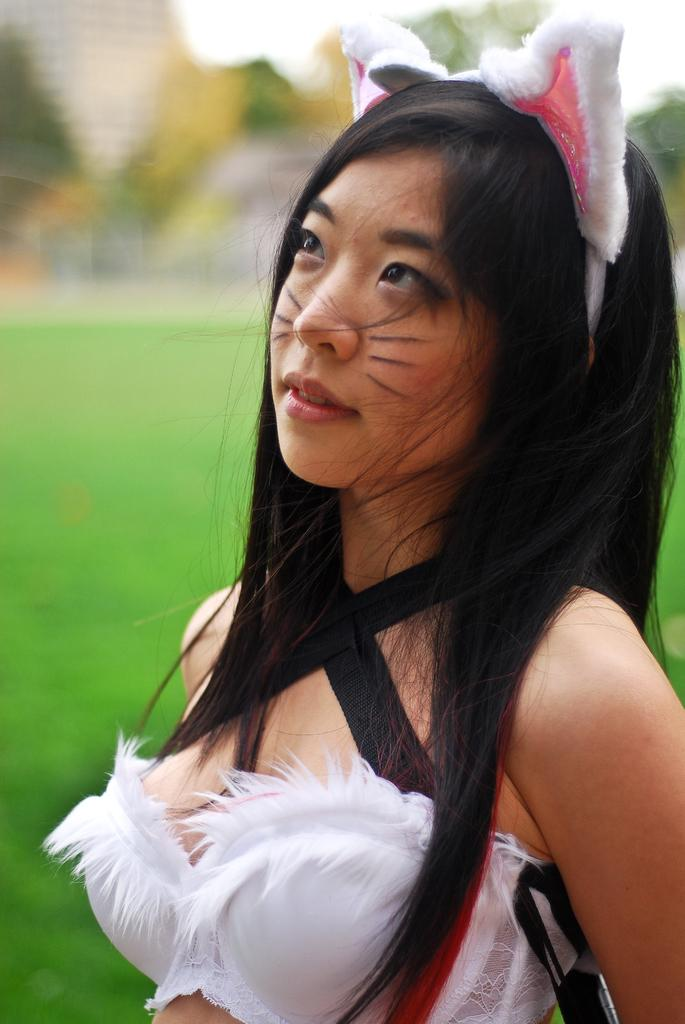Who is present in the image? There is a woman in the image. What is the woman wearing? The woman is wearing a white dress. What type of terrain is visible in the image? There is grass in the image. How would you describe the background of the image? The background of the image is blurred. What can be seen at the top of the image? The sky is visible at the top of the image. What type of leather is being used to sew the thread in the image? There is no leather or thread present in the image. 